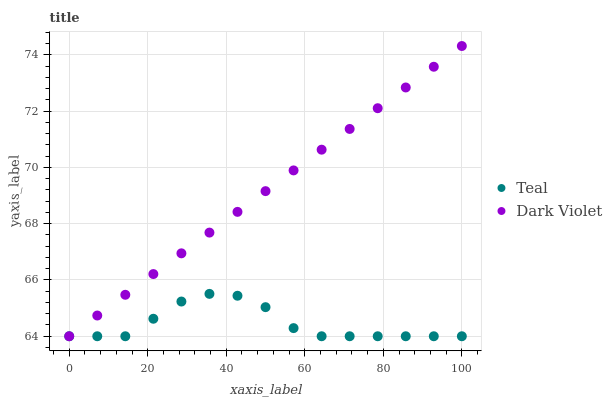Does Teal have the minimum area under the curve?
Answer yes or no. Yes. Does Dark Violet have the maximum area under the curve?
Answer yes or no. Yes. Does Teal have the maximum area under the curve?
Answer yes or no. No. Is Dark Violet the smoothest?
Answer yes or no. Yes. Is Teal the roughest?
Answer yes or no. Yes. Is Teal the smoothest?
Answer yes or no. No. Does Dark Violet have the lowest value?
Answer yes or no. Yes. Does Dark Violet have the highest value?
Answer yes or no. Yes. Does Teal have the highest value?
Answer yes or no. No. Does Teal intersect Dark Violet?
Answer yes or no. Yes. Is Teal less than Dark Violet?
Answer yes or no. No. Is Teal greater than Dark Violet?
Answer yes or no. No. 